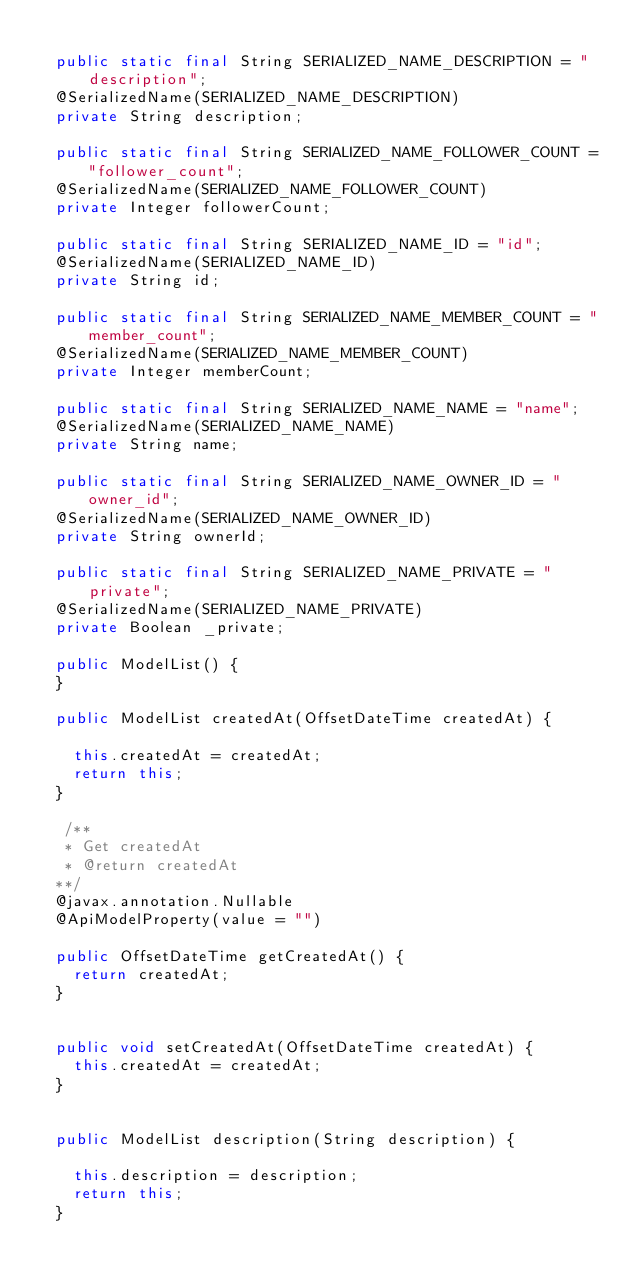<code> <loc_0><loc_0><loc_500><loc_500><_Java_>
  public static final String SERIALIZED_NAME_DESCRIPTION = "description";
  @SerializedName(SERIALIZED_NAME_DESCRIPTION)
  private String description;

  public static final String SERIALIZED_NAME_FOLLOWER_COUNT = "follower_count";
  @SerializedName(SERIALIZED_NAME_FOLLOWER_COUNT)
  private Integer followerCount;

  public static final String SERIALIZED_NAME_ID = "id";
  @SerializedName(SERIALIZED_NAME_ID)
  private String id;

  public static final String SERIALIZED_NAME_MEMBER_COUNT = "member_count";
  @SerializedName(SERIALIZED_NAME_MEMBER_COUNT)
  private Integer memberCount;

  public static final String SERIALIZED_NAME_NAME = "name";
  @SerializedName(SERIALIZED_NAME_NAME)
  private String name;

  public static final String SERIALIZED_NAME_OWNER_ID = "owner_id";
  @SerializedName(SERIALIZED_NAME_OWNER_ID)
  private String ownerId;

  public static final String SERIALIZED_NAME_PRIVATE = "private";
  @SerializedName(SERIALIZED_NAME_PRIVATE)
  private Boolean _private;

  public ModelList() { 
  }

  public ModelList createdAt(OffsetDateTime createdAt) {
    
    this.createdAt = createdAt;
    return this;
  }

   /**
   * Get createdAt
   * @return createdAt
  **/
  @javax.annotation.Nullable
  @ApiModelProperty(value = "")

  public OffsetDateTime getCreatedAt() {
    return createdAt;
  }


  public void setCreatedAt(OffsetDateTime createdAt) {
    this.createdAt = createdAt;
  }


  public ModelList description(String description) {
    
    this.description = description;
    return this;
  }
</code> 